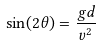<formula> <loc_0><loc_0><loc_500><loc_500>\sin ( 2 \theta ) = \frac { g d } { v ^ { 2 } }</formula> 